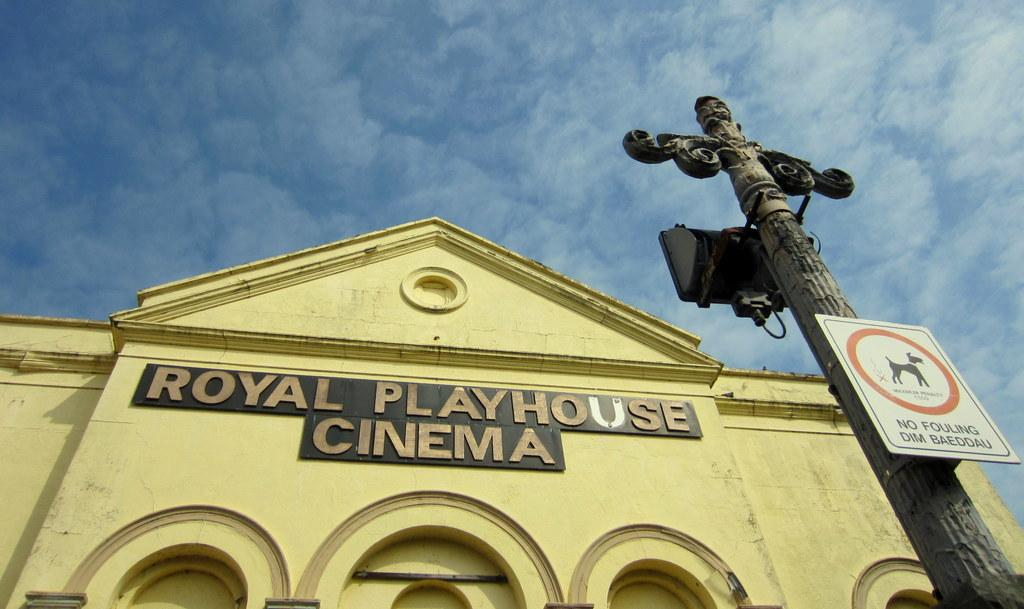Provide a one-sentence caption for the provided image. An upwards look at the outside of the Royal Playhouse Cinema. 